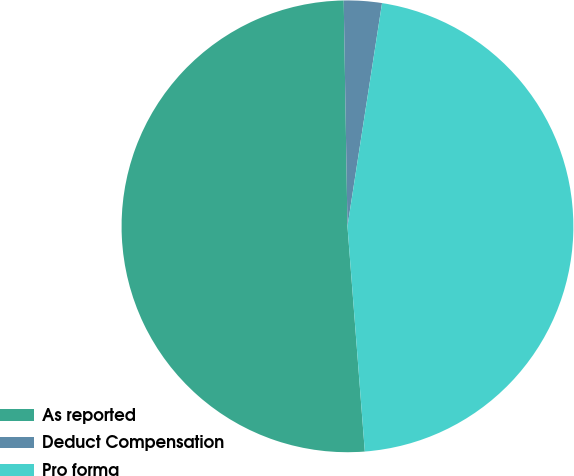Convert chart to OTSL. <chart><loc_0><loc_0><loc_500><loc_500><pie_chart><fcel>As reported<fcel>Deduct Compensation<fcel>Pro forma<nl><fcel>50.96%<fcel>2.71%<fcel>46.33%<nl></chart> 